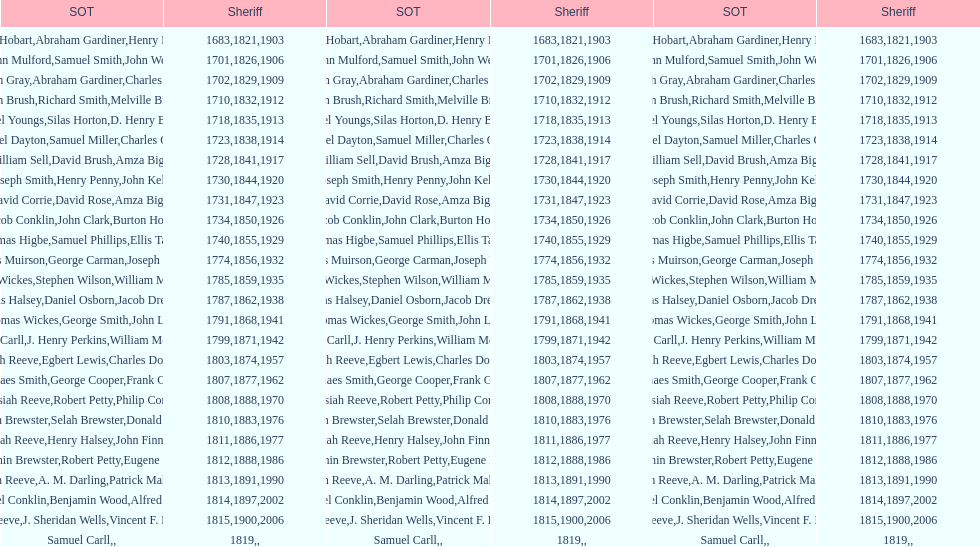Who was the sheriff in suffolk county before amza biggs first term there as sheriff? Charles O'Dell. 